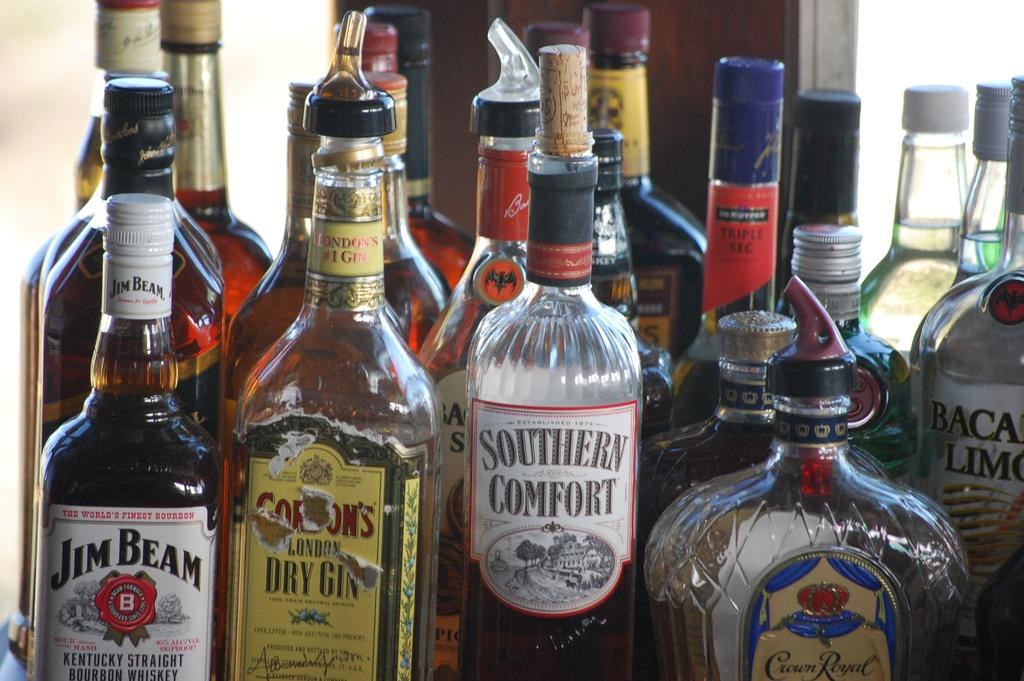<image>
Describe the image concisely. A bottle of Jim Beam is sitting next to a bottle of London's # 1 Gin. 